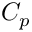Convert formula to latex. <formula><loc_0><loc_0><loc_500><loc_500>C _ { p }</formula> 